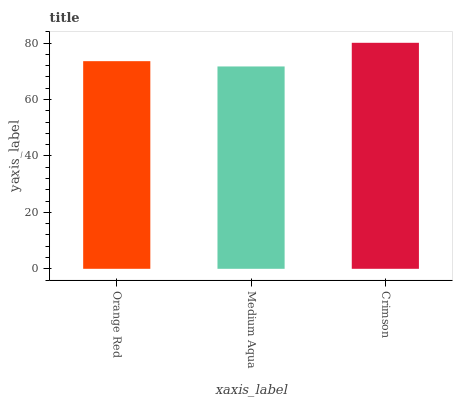Is Medium Aqua the minimum?
Answer yes or no. Yes. Is Crimson the maximum?
Answer yes or no. Yes. Is Crimson the minimum?
Answer yes or no. No. Is Medium Aqua the maximum?
Answer yes or no. No. Is Crimson greater than Medium Aqua?
Answer yes or no. Yes. Is Medium Aqua less than Crimson?
Answer yes or no. Yes. Is Medium Aqua greater than Crimson?
Answer yes or no. No. Is Crimson less than Medium Aqua?
Answer yes or no. No. Is Orange Red the high median?
Answer yes or no. Yes. Is Orange Red the low median?
Answer yes or no. Yes. Is Crimson the high median?
Answer yes or no. No. Is Medium Aqua the low median?
Answer yes or no. No. 